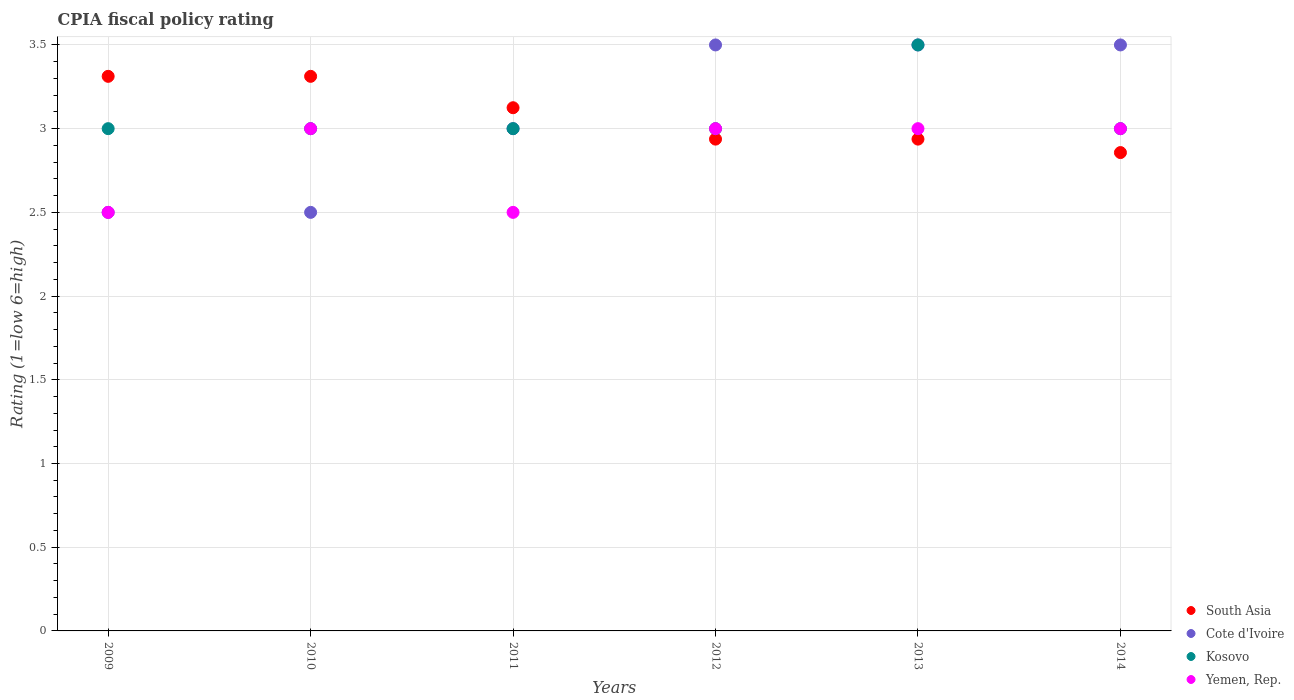What is the CPIA rating in Kosovo in 2013?
Your answer should be compact. 3.5. Across all years, what is the maximum CPIA rating in Cote d'Ivoire?
Keep it short and to the point. 3.5. Across all years, what is the minimum CPIA rating in Kosovo?
Provide a succinct answer. 3. What is the difference between the CPIA rating in South Asia in 2010 and that in 2013?
Offer a terse response. 0.38. What is the difference between the CPIA rating in Kosovo in 2014 and the CPIA rating in South Asia in 2009?
Provide a succinct answer. -0.31. What is the average CPIA rating in Kosovo per year?
Provide a short and direct response. 3.08. In the year 2012, what is the difference between the CPIA rating in South Asia and CPIA rating in Yemen, Rep.?
Provide a short and direct response. -0.06. In how many years, is the CPIA rating in Yemen, Rep. greater than 1.6?
Give a very brief answer. 6. What is the ratio of the CPIA rating in Kosovo in 2013 to that in 2014?
Your answer should be very brief. 1.17. Is the CPIA rating in Cote d'Ivoire in 2012 less than that in 2014?
Your answer should be very brief. No. What is the difference between the highest and the lowest CPIA rating in South Asia?
Provide a short and direct response. 0.46. Is it the case that in every year, the sum of the CPIA rating in South Asia and CPIA rating in Yemen, Rep.  is greater than the sum of CPIA rating in Kosovo and CPIA rating in Cote d'Ivoire?
Make the answer very short. Yes. Is it the case that in every year, the sum of the CPIA rating in South Asia and CPIA rating in Yemen, Rep.  is greater than the CPIA rating in Kosovo?
Make the answer very short. Yes. Is the CPIA rating in South Asia strictly less than the CPIA rating in Yemen, Rep. over the years?
Provide a short and direct response. No. How many dotlines are there?
Your answer should be very brief. 4. How many years are there in the graph?
Your response must be concise. 6. What is the difference between two consecutive major ticks on the Y-axis?
Your response must be concise. 0.5. Does the graph contain grids?
Provide a succinct answer. Yes. How many legend labels are there?
Your answer should be very brief. 4. How are the legend labels stacked?
Offer a terse response. Vertical. What is the title of the graph?
Provide a succinct answer. CPIA fiscal policy rating. What is the Rating (1=low 6=high) in South Asia in 2009?
Keep it short and to the point. 3.31. What is the Rating (1=low 6=high) of Kosovo in 2009?
Keep it short and to the point. 3. What is the Rating (1=low 6=high) in Yemen, Rep. in 2009?
Ensure brevity in your answer.  2.5. What is the Rating (1=low 6=high) of South Asia in 2010?
Give a very brief answer. 3.31. What is the Rating (1=low 6=high) in Kosovo in 2010?
Provide a short and direct response. 3. What is the Rating (1=low 6=high) in Yemen, Rep. in 2010?
Your answer should be very brief. 3. What is the Rating (1=low 6=high) of South Asia in 2011?
Offer a terse response. 3.12. What is the Rating (1=low 6=high) of Cote d'Ivoire in 2011?
Give a very brief answer. 3. What is the Rating (1=low 6=high) of Kosovo in 2011?
Your response must be concise. 3. What is the Rating (1=low 6=high) in Yemen, Rep. in 2011?
Provide a succinct answer. 2.5. What is the Rating (1=low 6=high) in South Asia in 2012?
Offer a terse response. 2.94. What is the Rating (1=low 6=high) of Cote d'Ivoire in 2012?
Ensure brevity in your answer.  3.5. What is the Rating (1=low 6=high) of Kosovo in 2012?
Offer a terse response. 3. What is the Rating (1=low 6=high) in Yemen, Rep. in 2012?
Offer a very short reply. 3. What is the Rating (1=low 6=high) in South Asia in 2013?
Give a very brief answer. 2.94. What is the Rating (1=low 6=high) of Cote d'Ivoire in 2013?
Your response must be concise. 3.5. What is the Rating (1=low 6=high) in South Asia in 2014?
Make the answer very short. 2.86. Across all years, what is the maximum Rating (1=low 6=high) in South Asia?
Make the answer very short. 3.31. Across all years, what is the maximum Rating (1=low 6=high) in Cote d'Ivoire?
Offer a very short reply. 3.5. Across all years, what is the maximum Rating (1=low 6=high) in Yemen, Rep.?
Make the answer very short. 3. Across all years, what is the minimum Rating (1=low 6=high) in South Asia?
Keep it short and to the point. 2.86. Across all years, what is the minimum Rating (1=low 6=high) in Kosovo?
Give a very brief answer. 3. What is the total Rating (1=low 6=high) of South Asia in the graph?
Keep it short and to the point. 18.48. What is the total Rating (1=low 6=high) of Cote d'Ivoire in the graph?
Offer a terse response. 18.5. What is the total Rating (1=low 6=high) in Kosovo in the graph?
Provide a short and direct response. 18.5. What is the difference between the Rating (1=low 6=high) in South Asia in 2009 and that in 2010?
Make the answer very short. 0. What is the difference between the Rating (1=low 6=high) of Cote d'Ivoire in 2009 and that in 2010?
Keep it short and to the point. 0. What is the difference between the Rating (1=low 6=high) of South Asia in 2009 and that in 2011?
Provide a succinct answer. 0.19. What is the difference between the Rating (1=low 6=high) in Kosovo in 2009 and that in 2011?
Give a very brief answer. 0. What is the difference between the Rating (1=low 6=high) in Cote d'Ivoire in 2009 and that in 2012?
Keep it short and to the point. -1. What is the difference between the Rating (1=low 6=high) of Yemen, Rep. in 2009 and that in 2012?
Keep it short and to the point. -0.5. What is the difference between the Rating (1=low 6=high) of Cote d'Ivoire in 2009 and that in 2013?
Offer a very short reply. -1. What is the difference between the Rating (1=low 6=high) in Kosovo in 2009 and that in 2013?
Make the answer very short. -0.5. What is the difference between the Rating (1=low 6=high) in Yemen, Rep. in 2009 and that in 2013?
Provide a short and direct response. -0.5. What is the difference between the Rating (1=low 6=high) of South Asia in 2009 and that in 2014?
Give a very brief answer. 0.46. What is the difference between the Rating (1=low 6=high) in Yemen, Rep. in 2009 and that in 2014?
Offer a terse response. -0.5. What is the difference between the Rating (1=low 6=high) in South Asia in 2010 and that in 2011?
Your answer should be very brief. 0.19. What is the difference between the Rating (1=low 6=high) in Cote d'Ivoire in 2010 and that in 2011?
Your response must be concise. -0.5. What is the difference between the Rating (1=low 6=high) of Kosovo in 2010 and that in 2011?
Offer a terse response. 0. What is the difference between the Rating (1=low 6=high) in Yemen, Rep. in 2010 and that in 2011?
Your answer should be compact. 0.5. What is the difference between the Rating (1=low 6=high) of Cote d'Ivoire in 2010 and that in 2012?
Your answer should be very brief. -1. What is the difference between the Rating (1=low 6=high) of Yemen, Rep. in 2010 and that in 2012?
Give a very brief answer. 0. What is the difference between the Rating (1=low 6=high) of Yemen, Rep. in 2010 and that in 2013?
Ensure brevity in your answer.  0. What is the difference between the Rating (1=low 6=high) in South Asia in 2010 and that in 2014?
Provide a succinct answer. 0.46. What is the difference between the Rating (1=low 6=high) in Cote d'Ivoire in 2010 and that in 2014?
Offer a very short reply. -1. What is the difference between the Rating (1=low 6=high) in South Asia in 2011 and that in 2012?
Make the answer very short. 0.19. What is the difference between the Rating (1=low 6=high) of Cote d'Ivoire in 2011 and that in 2012?
Your response must be concise. -0.5. What is the difference between the Rating (1=low 6=high) in Yemen, Rep. in 2011 and that in 2012?
Your answer should be compact. -0.5. What is the difference between the Rating (1=low 6=high) in South Asia in 2011 and that in 2013?
Give a very brief answer. 0.19. What is the difference between the Rating (1=low 6=high) in Cote d'Ivoire in 2011 and that in 2013?
Make the answer very short. -0.5. What is the difference between the Rating (1=low 6=high) in South Asia in 2011 and that in 2014?
Keep it short and to the point. 0.27. What is the difference between the Rating (1=low 6=high) of Cote d'Ivoire in 2011 and that in 2014?
Ensure brevity in your answer.  -0.5. What is the difference between the Rating (1=low 6=high) in Cote d'Ivoire in 2012 and that in 2013?
Your response must be concise. 0. What is the difference between the Rating (1=low 6=high) in South Asia in 2012 and that in 2014?
Your response must be concise. 0.08. What is the difference between the Rating (1=low 6=high) of Kosovo in 2012 and that in 2014?
Your answer should be very brief. 0. What is the difference between the Rating (1=low 6=high) of South Asia in 2013 and that in 2014?
Your answer should be very brief. 0.08. What is the difference between the Rating (1=low 6=high) in Cote d'Ivoire in 2013 and that in 2014?
Give a very brief answer. 0. What is the difference between the Rating (1=low 6=high) in Kosovo in 2013 and that in 2014?
Give a very brief answer. 0.5. What is the difference between the Rating (1=low 6=high) in South Asia in 2009 and the Rating (1=low 6=high) in Cote d'Ivoire in 2010?
Your response must be concise. 0.81. What is the difference between the Rating (1=low 6=high) of South Asia in 2009 and the Rating (1=low 6=high) of Kosovo in 2010?
Offer a terse response. 0.31. What is the difference between the Rating (1=low 6=high) of South Asia in 2009 and the Rating (1=low 6=high) of Yemen, Rep. in 2010?
Provide a succinct answer. 0.31. What is the difference between the Rating (1=low 6=high) of Cote d'Ivoire in 2009 and the Rating (1=low 6=high) of Kosovo in 2010?
Ensure brevity in your answer.  -0.5. What is the difference between the Rating (1=low 6=high) of Kosovo in 2009 and the Rating (1=low 6=high) of Yemen, Rep. in 2010?
Make the answer very short. 0. What is the difference between the Rating (1=low 6=high) of South Asia in 2009 and the Rating (1=low 6=high) of Cote d'Ivoire in 2011?
Give a very brief answer. 0.31. What is the difference between the Rating (1=low 6=high) in South Asia in 2009 and the Rating (1=low 6=high) in Kosovo in 2011?
Your response must be concise. 0.31. What is the difference between the Rating (1=low 6=high) in South Asia in 2009 and the Rating (1=low 6=high) in Yemen, Rep. in 2011?
Offer a terse response. 0.81. What is the difference between the Rating (1=low 6=high) in Cote d'Ivoire in 2009 and the Rating (1=low 6=high) in Kosovo in 2011?
Keep it short and to the point. -0.5. What is the difference between the Rating (1=low 6=high) of Cote d'Ivoire in 2009 and the Rating (1=low 6=high) of Yemen, Rep. in 2011?
Provide a succinct answer. 0. What is the difference between the Rating (1=low 6=high) in Kosovo in 2009 and the Rating (1=low 6=high) in Yemen, Rep. in 2011?
Give a very brief answer. 0.5. What is the difference between the Rating (1=low 6=high) in South Asia in 2009 and the Rating (1=low 6=high) in Cote d'Ivoire in 2012?
Provide a succinct answer. -0.19. What is the difference between the Rating (1=low 6=high) in South Asia in 2009 and the Rating (1=low 6=high) in Kosovo in 2012?
Your answer should be very brief. 0.31. What is the difference between the Rating (1=low 6=high) of South Asia in 2009 and the Rating (1=low 6=high) of Yemen, Rep. in 2012?
Ensure brevity in your answer.  0.31. What is the difference between the Rating (1=low 6=high) in Kosovo in 2009 and the Rating (1=low 6=high) in Yemen, Rep. in 2012?
Give a very brief answer. 0. What is the difference between the Rating (1=low 6=high) in South Asia in 2009 and the Rating (1=low 6=high) in Cote d'Ivoire in 2013?
Make the answer very short. -0.19. What is the difference between the Rating (1=low 6=high) of South Asia in 2009 and the Rating (1=low 6=high) of Kosovo in 2013?
Provide a succinct answer. -0.19. What is the difference between the Rating (1=low 6=high) of South Asia in 2009 and the Rating (1=low 6=high) of Yemen, Rep. in 2013?
Give a very brief answer. 0.31. What is the difference between the Rating (1=low 6=high) in Cote d'Ivoire in 2009 and the Rating (1=low 6=high) in Kosovo in 2013?
Your answer should be compact. -1. What is the difference between the Rating (1=low 6=high) in Cote d'Ivoire in 2009 and the Rating (1=low 6=high) in Yemen, Rep. in 2013?
Your response must be concise. -0.5. What is the difference between the Rating (1=low 6=high) of Kosovo in 2009 and the Rating (1=low 6=high) of Yemen, Rep. in 2013?
Keep it short and to the point. 0. What is the difference between the Rating (1=low 6=high) in South Asia in 2009 and the Rating (1=low 6=high) in Cote d'Ivoire in 2014?
Give a very brief answer. -0.19. What is the difference between the Rating (1=low 6=high) in South Asia in 2009 and the Rating (1=low 6=high) in Kosovo in 2014?
Offer a very short reply. 0.31. What is the difference between the Rating (1=low 6=high) of South Asia in 2009 and the Rating (1=low 6=high) of Yemen, Rep. in 2014?
Provide a short and direct response. 0.31. What is the difference between the Rating (1=low 6=high) in Cote d'Ivoire in 2009 and the Rating (1=low 6=high) in Kosovo in 2014?
Make the answer very short. -0.5. What is the difference between the Rating (1=low 6=high) of Kosovo in 2009 and the Rating (1=low 6=high) of Yemen, Rep. in 2014?
Offer a terse response. 0. What is the difference between the Rating (1=low 6=high) of South Asia in 2010 and the Rating (1=low 6=high) of Cote d'Ivoire in 2011?
Provide a succinct answer. 0.31. What is the difference between the Rating (1=low 6=high) in South Asia in 2010 and the Rating (1=low 6=high) in Kosovo in 2011?
Your answer should be compact. 0.31. What is the difference between the Rating (1=low 6=high) of South Asia in 2010 and the Rating (1=low 6=high) of Yemen, Rep. in 2011?
Your answer should be compact. 0.81. What is the difference between the Rating (1=low 6=high) in Cote d'Ivoire in 2010 and the Rating (1=low 6=high) in Kosovo in 2011?
Offer a terse response. -0.5. What is the difference between the Rating (1=low 6=high) of Kosovo in 2010 and the Rating (1=low 6=high) of Yemen, Rep. in 2011?
Provide a short and direct response. 0.5. What is the difference between the Rating (1=low 6=high) of South Asia in 2010 and the Rating (1=low 6=high) of Cote d'Ivoire in 2012?
Your response must be concise. -0.19. What is the difference between the Rating (1=low 6=high) in South Asia in 2010 and the Rating (1=low 6=high) in Kosovo in 2012?
Give a very brief answer. 0.31. What is the difference between the Rating (1=low 6=high) in South Asia in 2010 and the Rating (1=low 6=high) in Yemen, Rep. in 2012?
Provide a short and direct response. 0.31. What is the difference between the Rating (1=low 6=high) in Kosovo in 2010 and the Rating (1=low 6=high) in Yemen, Rep. in 2012?
Your answer should be very brief. 0. What is the difference between the Rating (1=low 6=high) of South Asia in 2010 and the Rating (1=low 6=high) of Cote d'Ivoire in 2013?
Offer a terse response. -0.19. What is the difference between the Rating (1=low 6=high) in South Asia in 2010 and the Rating (1=low 6=high) in Kosovo in 2013?
Offer a very short reply. -0.19. What is the difference between the Rating (1=low 6=high) of South Asia in 2010 and the Rating (1=low 6=high) of Yemen, Rep. in 2013?
Your answer should be compact. 0.31. What is the difference between the Rating (1=low 6=high) in Cote d'Ivoire in 2010 and the Rating (1=low 6=high) in Kosovo in 2013?
Provide a succinct answer. -1. What is the difference between the Rating (1=low 6=high) of Cote d'Ivoire in 2010 and the Rating (1=low 6=high) of Yemen, Rep. in 2013?
Your answer should be compact. -0.5. What is the difference between the Rating (1=low 6=high) of South Asia in 2010 and the Rating (1=low 6=high) of Cote d'Ivoire in 2014?
Offer a terse response. -0.19. What is the difference between the Rating (1=low 6=high) in South Asia in 2010 and the Rating (1=low 6=high) in Kosovo in 2014?
Offer a very short reply. 0.31. What is the difference between the Rating (1=low 6=high) of South Asia in 2010 and the Rating (1=low 6=high) of Yemen, Rep. in 2014?
Keep it short and to the point. 0.31. What is the difference between the Rating (1=low 6=high) of Cote d'Ivoire in 2010 and the Rating (1=low 6=high) of Kosovo in 2014?
Your answer should be compact. -0.5. What is the difference between the Rating (1=low 6=high) of Cote d'Ivoire in 2010 and the Rating (1=low 6=high) of Yemen, Rep. in 2014?
Offer a very short reply. -0.5. What is the difference between the Rating (1=low 6=high) of Kosovo in 2010 and the Rating (1=low 6=high) of Yemen, Rep. in 2014?
Your answer should be very brief. 0. What is the difference between the Rating (1=low 6=high) of South Asia in 2011 and the Rating (1=low 6=high) of Cote d'Ivoire in 2012?
Ensure brevity in your answer.  -0.38. What is the difference between the Rating (1=low 6=high) of Cote d'Ivoire in 2011 and the Rating (1=low 6=high) of Kosovo in 2012?
Make the answer very short. 0. What is the difference between the Rating (1=low 6=high) in Cote d'Ivoire in 2011 and the Rating (1=low 6=high) in Yemen, Rep. in 2012?
Your answer should be compact. 0. What is the difference between the Rating (1=low 6=high) in Kosovo in 2011 and the Rating (1=low 6=high) in Yemen, Rep. in 2012?
Keep it short and to the point. 0. What is the difference between the Rating (1=low 6=high) in South Asia in 2011 and the Rating (1=low 6=high) in Cote d'Ivoire in 2013?
Your response must be concise. -0.38. What is the difference between the Rating (1=low 6=high) of South Asia in 2011 and the Rating (1=low 6=high) of Kosovo in 2013?
Your response must be concise. -0.38. What is the difference between the Rating (1=low 6=high) of South Asia in 2011 and the Rating (1=low 6=high) of Yemen, Rep. in 2013?
Make the answer very short. 0.12. What is the difference between the Rating (1=low 6=high) of Cote d'Ivoire in 2011 and the Rating (1=low 6=high) of Kosovo in 2013?
Make the answer very short. -0.5. What is the difference between the Rating (1=low 6=high) of South Asia in 2011 and the Rating (1=low 6=high) of Cote d'Ivoire in 2014?
Offer a very short reply. -0.38. What is the difference between the Rating (1=low 6=high) of South Asia in 2011 and the Rating (1=low 6=high) of Yemen, Rep. in 2014?
Offer a terse response. 0.12. What is the difference between the Rating (1=low 6=high) in Cote d'Ivoire in 2011 and the Rating (1=low 6=high) in Yemen, Rep. in 2014?
Provide a succinct answer. 0. What is the difference between the Rating (1=low 6=high) of Kosovo in 2011 and the Rating (1=low 6=high) of Yemen, Rep. in 2014?
Your answer should be very brief. 0. What is the difference between the Rating (1=low 6=high) in South Asia in 2012 and the Rating (1=low 6=high) in Cote d'Ivoire in 2013?
Ensure brevity in your answer.  -0.56. What is the difference between the Rating (1=low 6=high) in South Asia in 2012 and the Rating (1=low 6=high) in Kosovo in 2013?
Offer a terse response. -0.56. What is the difference between the Rating (1=low 6=high) in South Asia in 2012 and the Rating (1=low 6=high) in Yemen, Rep. in 2013?
Offer a very short reply. -0.06. What is the difference between the Rating (1=low 6=high) in Cote d'Ivoire in 2012 and the Rating (1=low 6=high) in Yemen, Rep. in 2013?
Keep it short and to the point. 0.5. What is the difference between the Rating (1=low 6=high) in Kosovo in 2012 and the Rating (1=low 6=high) in Yemen, Rep. in 2013?
Give a very brief answer. 0. What is the difference between the Rating (1=low 6=high) in South Asia in 2012 and the Rating (1=low 6=high) in Cote d'Ivoire in 2014?
Ensure brevity in your answer.  -0.56. What is the difference between the Rating (1=low 6=high) in South Asia in 2012 and the Rating (1=low 6=high) in Kosovo in 2014?
Provide a short and direct response. -0.06. What is the difference between the Rating (1=low 6=high) of South Asia in 2012 and the Rating (1=low 6=high) of Yemen, Rep. in 2014?
Give a very brief answer. -0.06. What is the difference between the Rating (1=low 6=high) in South Asia in 2013 and the Rating (1=low 6=high) in Cote d'Ivoire in 2014?
Ensure brevity in your answer.  -0.56. What is the difference between the Rating (1=low 6=high) in South Asia in 2013 and the Rating (1=low 6=high) in Kosovo in 2014?
Give a very brief answer. -0.06. What is the difference between the Rating (1=low 6=high) in South Asia in 2013 and the Rating (1=low 6=high) in Yemen, Rep. in 2014?
Provide a short and direct response. -0.06. What is the difference between the Rating (1=low 6=high) of Kosovo in 2013 and the Rating (1=low 6=high) of Yemen, Rep. in 2014?
Ensure brevity in your answer.  0.5. What is the average Rating (1=low 6=high) in South Asia per year?
Provide a short and direct response. 3.08. What is the average Rating (1=low 6=high) of Cote d'Ivoire per year?
Give a very brief answer. 3.08. What is the average Rating (1=low 6=high) in Kosovo per year?
Provide a succinct answer. 3.08. What is the average Rating (1=low 6=high) in Yemen, Rep. per year?
Your answer should be very brief. 2.83. In the year 2009, what is the difference between the Rating (1=low 6=high) of South Asia and Rating (1=low 6=high) of Cote d'Ivoire?
Make the answer very short. 0.81. In the year 2009, what is the difference between the Rating (1=low 6=high) of South Asia and Rating (1=low 6=high) of Kosovo?
Provide a short and direct response. 0.31. In the year 2009, what is the difference between the Rating (1=low 6=high) of South Asia and Rating (1=low 6=high) of Yemen, Rep.?
Ensure brevity in your answer.  0.81. In the year 2009, what is the difference between the Rating (1=low 6=high) of Cote d'Ivoire and Rating (1=low 6=high) of Kosovo?
Offer a terse response. -0.5. In the year 2010, what is the difference between the Rating (1=low 6=high) of South Asia and Rating (1=low 6=high) of Cote d'Ivoire?
Give a very brief answer. 0.81. In the year 2010, what is the difference between the Rating (1=low 6=high) in South Asia and Rating (1=low 6=high) in Kosovo?
Your answer should be compact. 0.31. In the year 2010, what is the difference between the Rating (1=low 6=high) in South Asia and Rating (1=low 6=high) in Yemen, Rep.?
Your answer should be very brief. 0.31. In the year 2010, what is the difference between the Rating (1=low 6=high) of Cote d'Ivoire and Rating (1=low 6=high) of Kosovo?
Offer a terse response. -0.5. In the year 2010, what is the difference between the Rating (1=low 6=high) of Cote d'Ivoire and Rating (1=low 6=high) of Yemen, Rep.?
Provide a short and direct response. -0.5. In the year 2011, what is the difference between the Rating (1=low 6=high) in South Asia and Rating (1=low 6=high) in Cote d'Ivoire?
Make the answer very short. 0.12. In the year 2011, what is the difference between the Rating (1=low 6=high) of South Asia and Rating (1=low 6=high) of Yemen, Rep.?
Offer a very short reply. 0.62. In the year 2011, what is the difference between the Rating (1=low 6=high) in Cote d'Ivoire and Rating (1=low 6=high) in Yemen, Rep.?
Your answer should be compact. 0.5. In the year 2011, what is the difference between the Rating (1=low 6=high) of Kosovo and Rating (1=low 6=high) of Yemen, Rep.?
Offer a terse response. 0.5. In the year 2012, what is the difference between the Rating (1=low 6=high) of South Asia and Rating (1=low 6=high) of Cote d'Ivoire?
Your answer should be compact. -0.56. In the year 2012, what is the difference between the Rating (1=low 6=high) of South Asia and Rating (1=low 6=high) of Kosovo?
Your response must be concise. -0.06. In the year 2012, what is the difference between the Rating (1=low 6=high) of South Asia and Rating (1=low 6=high) of Yemen, Rep.?
Ensure brevity in your answer.  -0.06. In the year 2012, what is the difference between the Rating (1=low 6=high) of Kosovo and Rating (1=low 6=high) of Yemen, Rep.?
Offer a terse response. 0. In the year 2013, what is the difference between the Rating (1=low 6=high) of South Asia and Rating (1=low 6=high) of Cote d'Ivoire?
Offer a terse response. -0.56. In the year 2013, what is the difference between the Rating (1=low 6=high) of South Asia and Rating (1=low 6=high) of Kosovo?
Your answer should be compact. -0.56. In the year 2013, what is the difference between the Rating (1=low 6=high) in South Asia and Rating (1=low 6=high) in Yemen, Rep.?
Your answer should be compact. -0.06. In the year 2014, what is the difference between the Rating (1=low 6=high) of South Asia and Rating (1=low 6=high) of Cote d'Ivoire?
Give a very brief answer. -0.64. In the year 2014, what is the difference between the Rating (1=low 6=high) in South Asia and Rating (1=low 6=high) in Kosovo?
Provide a short and direct response. -0.14. In the year 2014, what is the difference between the Rating (1=low 6=high) in South Asia and Rating (1=low 6=high) in Yemen, Rep.?
Give a very brief answer. -0.14. What is the ratio of the Rating (1=low 6=high) in South Asia in 2009 to that in 2010?
Provide a short and direct response. 1. What is the ratio of the Rating (1=low 6=high) of South Asia in 2009 to that in 2011?
Give a very brief answer. 1.06. What is the ratio of the Rating (1=low 6=high) in Kosovo in 2009 to that in 2011?
Offer a very short reply. 1. What is the ratio of the Rating (1=low 6=high) in South Asia in 2009 to that in 2012?
Offer a very short reply. 1.13. What is the ratio of the Rating (1=low 6=high) of Cote d'Ivoire in 2009 to that in 2012?
Your answer should be compact. 0.71. What is the ratio of the Rating (1=low 6=high) of Yemen, Rep. in 2009 to that in 2012?
Offer a very short reply. 0.83. What is the ratio of the Rating (1=low 6=high) of South Asia in 2009 to that in 2013?
Your answer should be compact. 1.13. What is the ratio of the Rating (1=low 6=high) in South Asia in 2009 to that in 2014?
Your response must be concise. 1.16. What is the ratio of the Rating (1=low 6=high) of South Asia in 2010 to that in 2011?
Offer a very short reply. 1.06. What is the ratio of the Rating (1=low 6=high) of Kosovo in 2010 to that in 2011?
Make the answer very short. 1. What is the ratio of the Rating (1=low 6=high) of Yemen, Rep. in 2010 to that in 2011?
Your answer should be very brief. 1.2. What is the ratio of the Rating (1=low 6=high) of South Asia in 2010 to that in 2012?
Your answer should be compact. 1.13. What is the ratio of the Rating (1=low 6=high) of Yemen, Rep. in 2010 to that in 2012?
Offer a very short reply. 1. What is the ratio of the Rating (1=low 6=high) in South Asia in 2010 to that in 2013?
Offer a very short reply. 1.13. What is the ratio of the Rating (1=low 6=high) in Cote d'Ivoire in 2010 to that in 2013?
Ensure brevity in your answer.  0.71. What is the ratio of the Rating (1=low 6=high) in Kosovo in 2010 to that in 2013?
Provide a succinct answer. 0.86. What is the ratio of the Rating (1=low 6=high) of South Asia in 2010 to that in 2014?
Your answer should be compact. 1.16. What is the ratio of the Rating (1=low 6=high) of South Asia in 2011 to that in 2012?
Offer a very short reply. 1.06. What is the ratio of the Rating (1=low 6=high) in Kosovo in 2011 to that in 2012?
Provide a succinct answer. 1. What is the ratio of the Rating (1=low 6=high) in Yemen, Rep. in 2011 to that in 2012?
Your answer should be compact. 0.83. What is the ratio of the Rating (1=low 6=high) in South Asia in 2011 to that in 2013?
Ensure brevity in your answer.  1.06. What is the ratio of the Rating (1=low 6=high) of Kosovo in 2011 to that in 2013?
Give a very brief answer. 0.86. What is the ratio of the Rating (1=low 6=high) of Yemen, Rep. in 2011 to that in 2013?
Your response must be concise. 0.83. What is the ratio of the Rating (1=low 6=high) of South Asia in 2011 to that in 2014?
Keep it short and to the point. 1.09. What is the ratio of the Rating (1=low 6=high) in Cote d'Ivoire in 2011 to that in 2014?
Provide a short and direct response. 0.86. What is the ratio of the Rating (1=low 6=high) in Kosovo in 2011 to that in 2014?
Make the answer very short. 1. What is the ratio of the Rating (1=low 6=high) in South Asia in 2012 to that in 2013?
Offer a very short reply. 1. What is the ratio of the Rating (1=low 6=high) of Kosovo in 2012 to that in 2013?
Your answer should be very brief. 0.86. What is the ratio of the Rating (1=low 6=high) of Yemen, Rep. in 2012 to that in 2013?
Provide a succinct answer. 1. What is the ratio of the Rating (1=low 6=high) of South Asia in 2012 to that in 2014?
Offer a terse response. 1.03. What is the ratio of the Rating (1=low 6=high) of Yemen, Rep. in 2012 to that in 2014?
Your response must be concise. 1. What is the ratio of the Rating (1=low 6=high) in South Asia in 2013 to that in 2014?
Provide a short and direct response. 1.03. What is the ratio of the Rating (1=low 6=high) in Kosovo in 2013 to that in 2014?
Give a very brief answer. 1.17. What is the difference between the highest and the second highest Rating (1=low 6=high) in Cote d'Ivoire?
Offer a very short reply. 0. What is the difference between the highest and the second highest Rating (1=low 6=high) of Kosovo?
Offer a very short reply. 0.5. What is the difference between the highest and the lowest Rating (1=low 6=high) of South Asia?
Offer a very short reply. 0.46. What is the difference between the highest and the lowest Rating (1=low 6=high) of Cote d'Ivoire?
Offer a terse response. 1. What is the difference between the highest and the lowest Rating (1=low 6=high) of Kosovo?
Provide a short and direct response. 0.5. What is the difference between the highest and the lowest Rating (1=low 6=high) in Yemen, Rep.?
Provide a succinct answer. 0.5. 